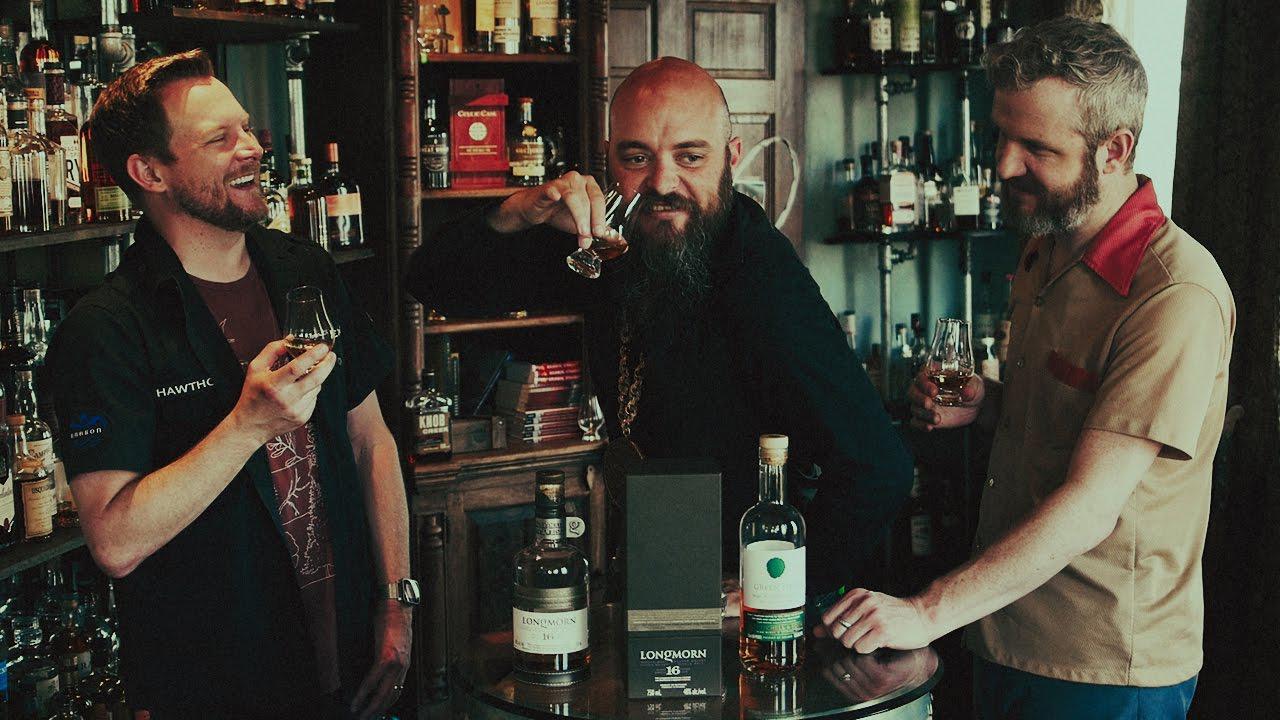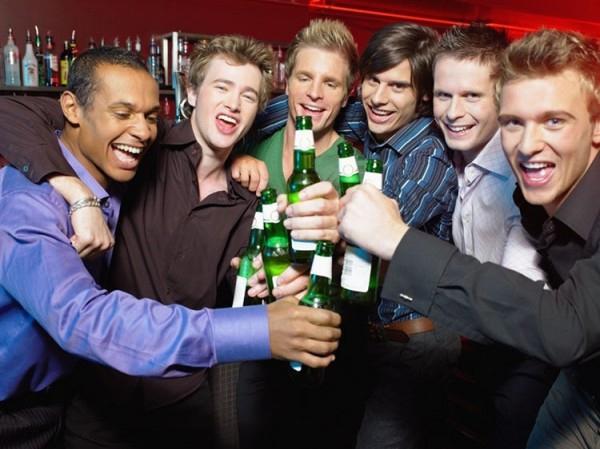The first image is the image on the left, the second image is the image on the right. Evaluate the accuracy of this statement regarding the images: "There are a total of nine people.". Is it true? Answer yes or no. Yes. The first image is the image on the left, the second image is the image on the right. For the images displayed, is the sentence "A man is holding a bottle to his mouth." factually correct? Answer yes or no. No. 